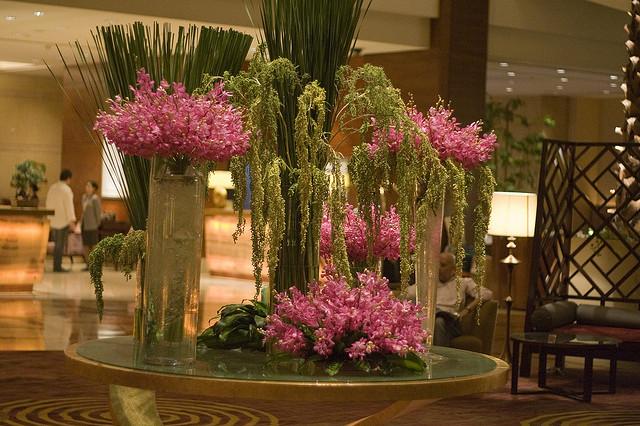What color is the flower vase?
Concise answer only. Clear. Does the table seem to be floating or are it's legs clearly evident?
Be succinct. Clearly evident. Were these flowers given for a special occasion?
Write a very short answer. No. Are the vases the same size?
Be succinct. No. What color are flowers?
Short answer required. Pink. What shape is the table?
Be succinct. Round. Are there any vegetables on the table?
Quick response, please. No. Is this picture taken in someone's home?
Give a very brief answer. No. What color of flowers are in this vase?
Quick response, please. Pink. 